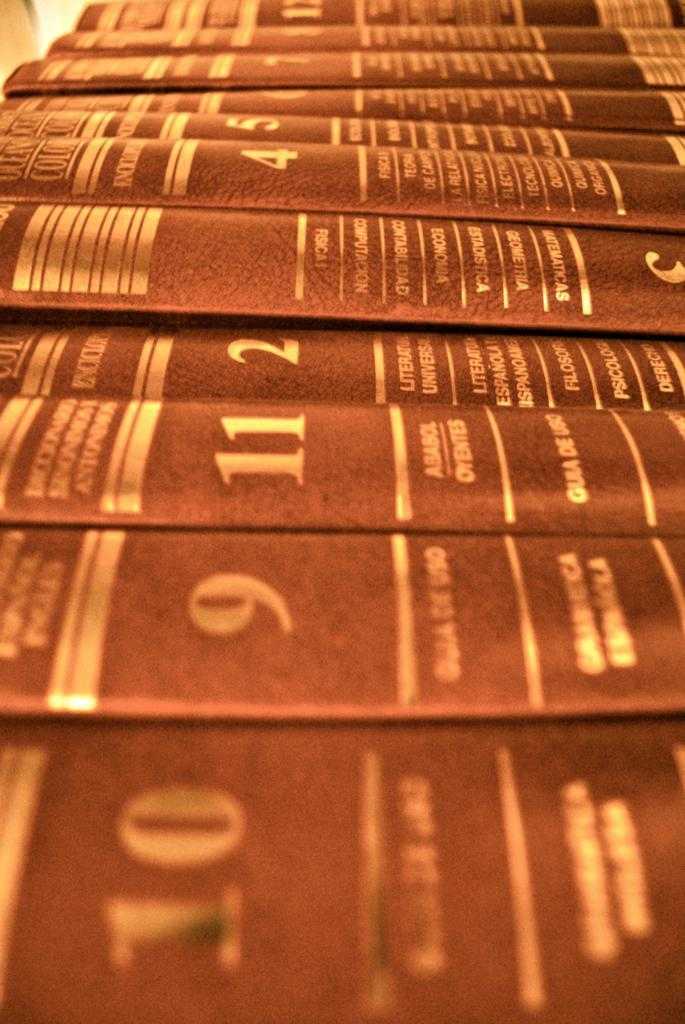<image>
Present a compact description of the photo's key features. A group of eleven books in a row with book number three turned upside down. 